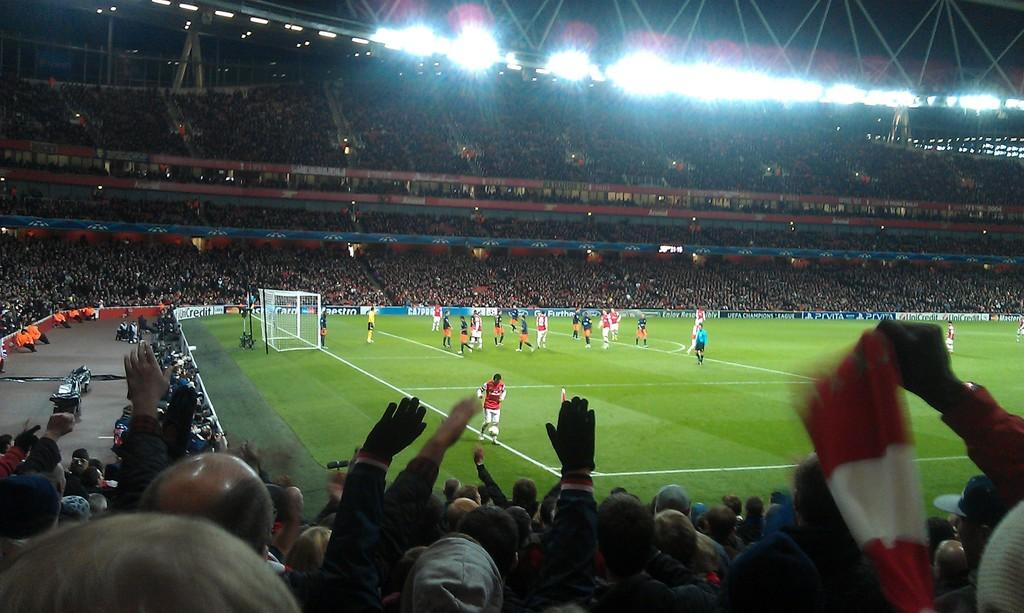What can be seen in the image involving people? There are players in the image. Where are the players located? The players are on a ground. What is the surrounding environment like for the players? There is a crowd sitting around the players. What can be seen in the background of the image? Ceiling lights are visible in the background of the image. How many geese are flying above the players in the image? There are no geese present in the image; it only features players, a crowd, and ceiling lights. 